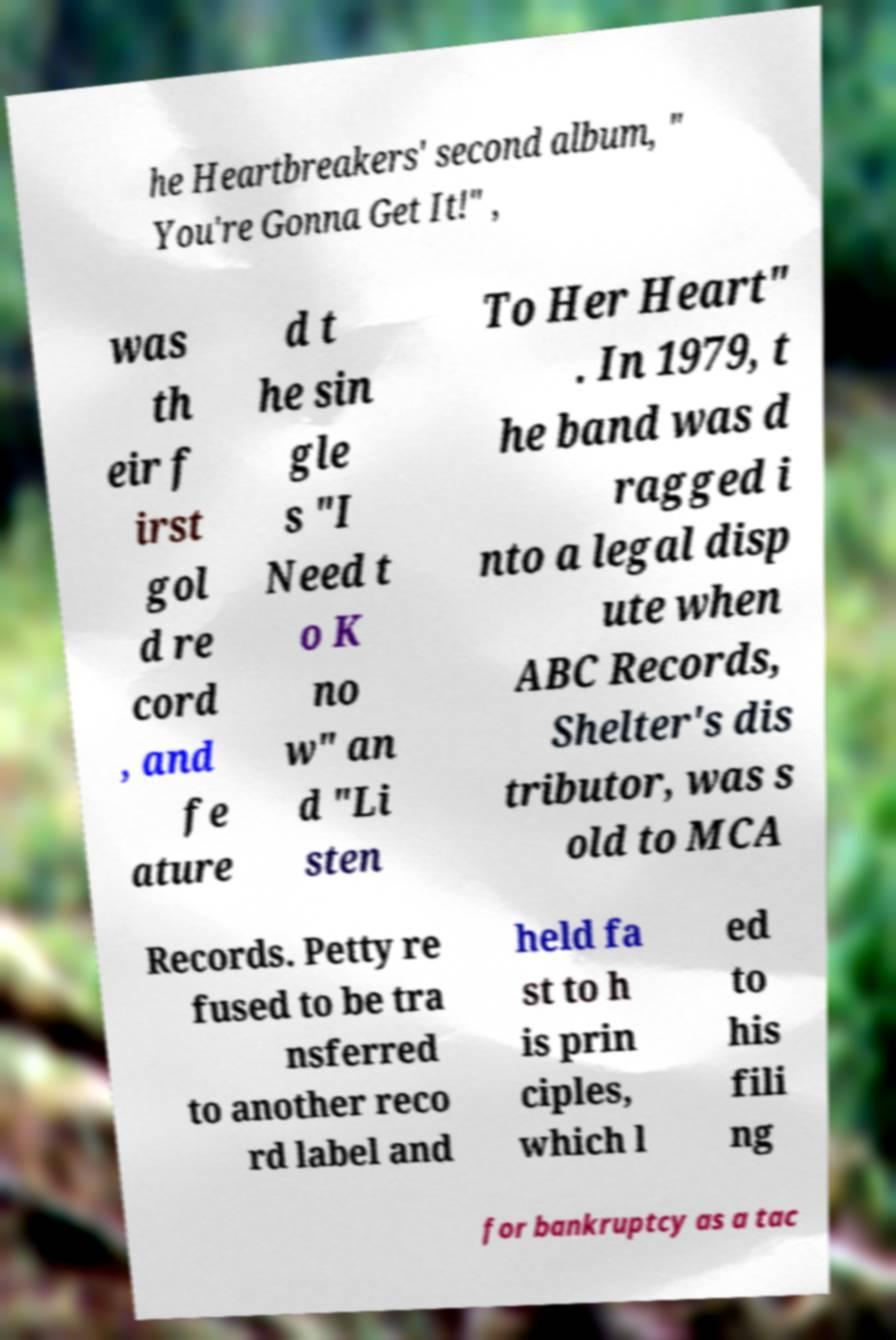Could you extract and type out the text from this image? he Heartbreakers' second album, " You're Gonna Get It!" , was th eir f irst gol d re cord , and fe ature d t he sin gle s "I Need t o K no w" an d "Li sten To Her Heart" . In 1979, t he band was d ragged i nto a legal disp ute when ABC Records, Shelter's dis tributor, was s old to MCA Records. Petty re fused to be tra nsferred to another reco rd label and held fa st to h is prin ciples, which l ed to his fili ng for bankruptcy as a tac 